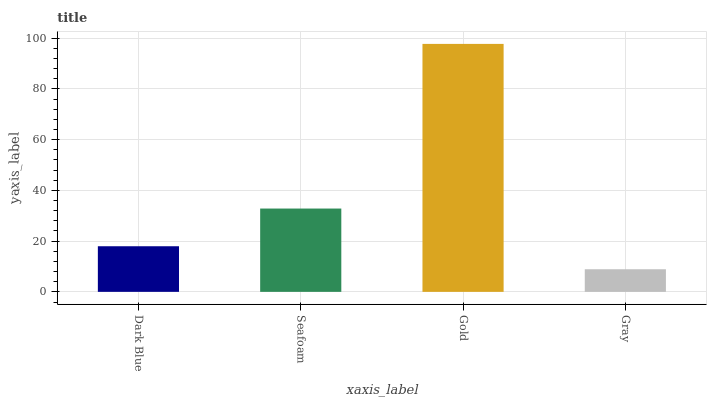Is Seafoam the minimum?
Answer yes or no. No. Is Seafoam the maximum?
Answer yes or no. No. Is Seafoam greater than Dark Blue?
Answer yes or no. Yes. Is Dark Blue less than Seafoam?
Answer yes or no. Yes. Is Dark Blue greater than Seafoam?
Answer yes or no. No. Is Seafoam less than Dark Blue?
Answer yes or no. No. Is Seafoam the high median?
Answer yes or no. Yes. Is Dark Blue the low median?
Answer yes or no. Yes. Is Gold the high median?
Answer yes or no. No. Is Seafoam the low median?
Answer yes or no. No. 